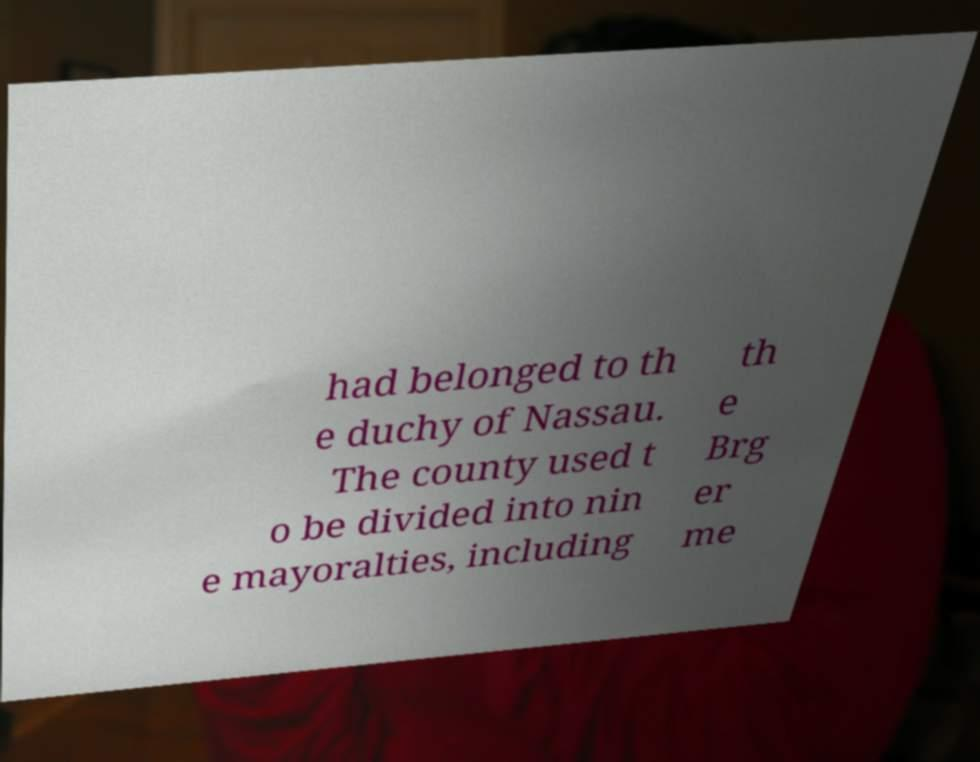Can you accurately transcribe the text from the provided image for me? had belonged to th e duchy of Nassau. The county used t o be divided into nin e mayoralties, including th e Brg er me 